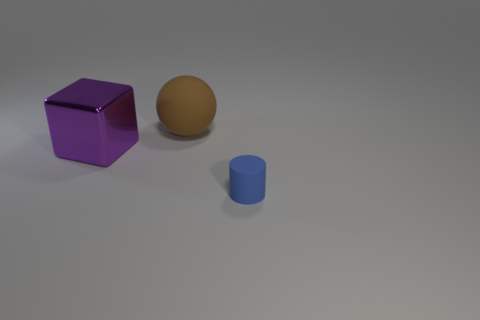How many other things have the same material as the tiny blue object?
Ensure brevity in your answer.  1. There is a rubber thing behind the purple metal cube; does it have the same size as the big purple metallic cube?
Provide a succinct answer. Yes. The matte sphere that is the same size as the purple metallic cube is what color?
Keep it short and to the point. Brown. What number of matte balls are left of the blue matte cylinder?
Ensure brevity in your answer.  1. Are there any purple objects?
Keep it short and to the point. Yes. There is a rubber object that is to the left of the thing on the right side of the ball that is behind the metallic object; what is its size?
Provide a succinct answer. Large. What number of other things are there of the same size as the purple shiny cube?
Provide a short and direct response. 1. What is the size of the object in front of the purple thing?
Provide a short and direct response. Small. Are there any other things of the same color as the small rubber cylinder?
Give a very brief answer. No. Is the thing that is behind the shiny block made of the same material as the large cube?
Offer a terse response. No. 